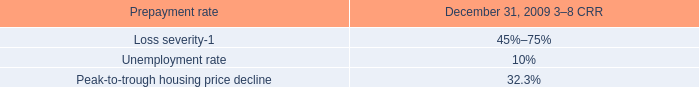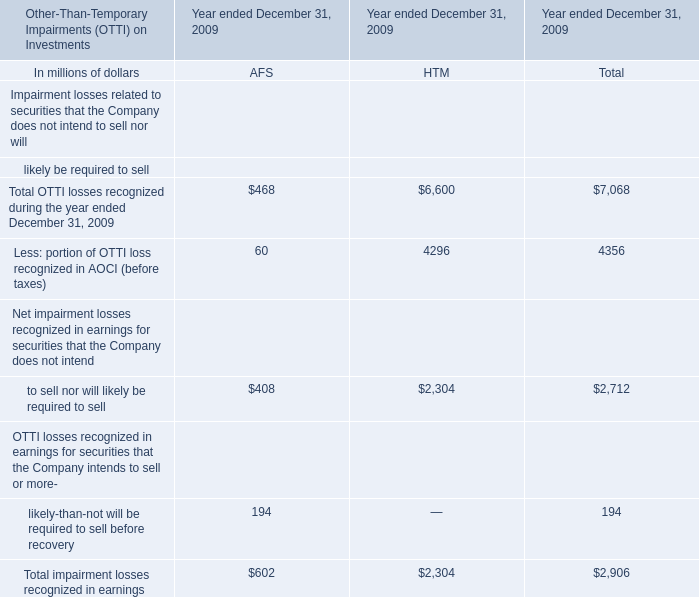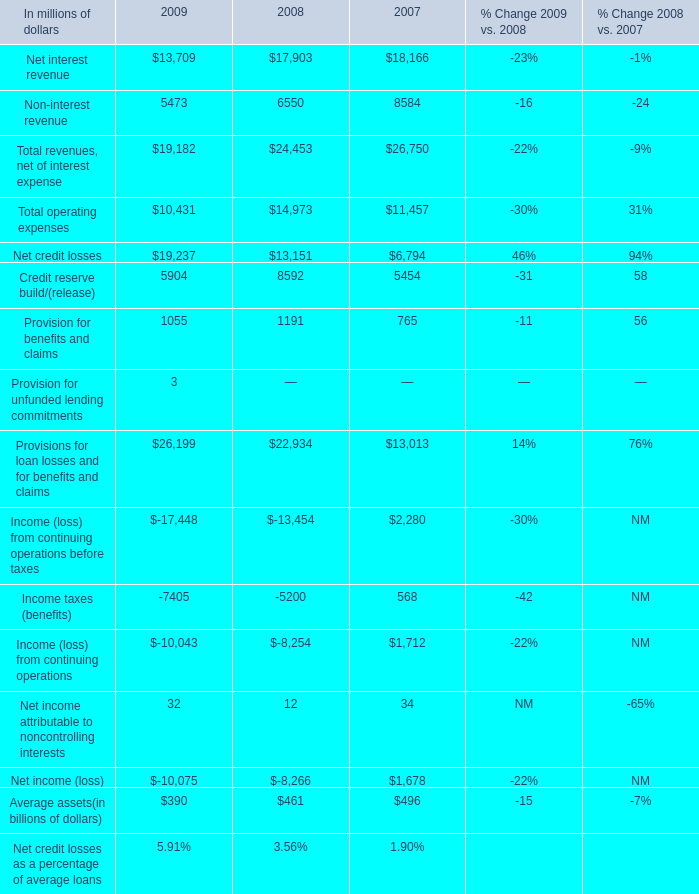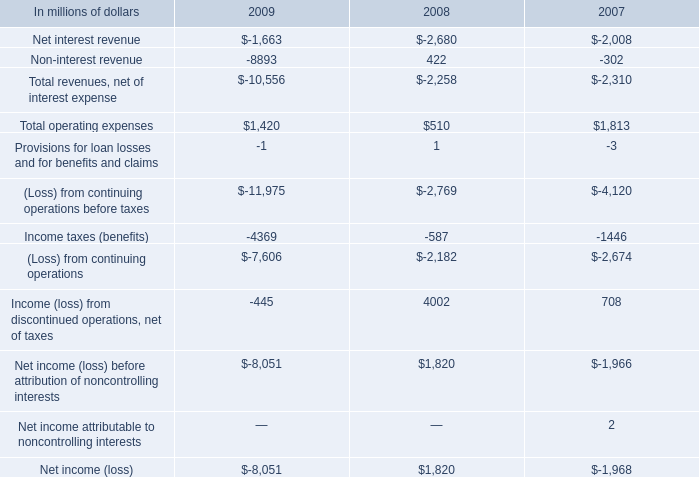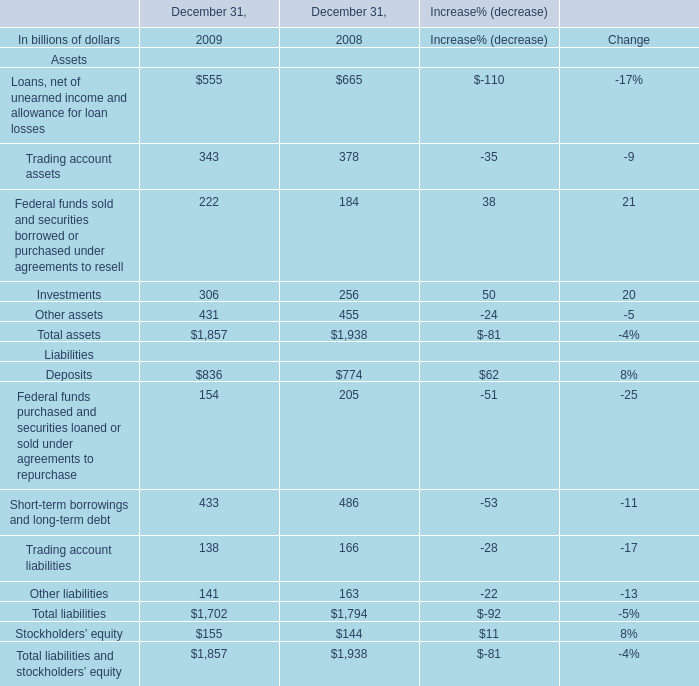What is the sum of assets in the range of 200 and 500 in 2009? (in billion) 
Computations: (((343 + 222) + 306) + 431)
Answer: 1302.0. 